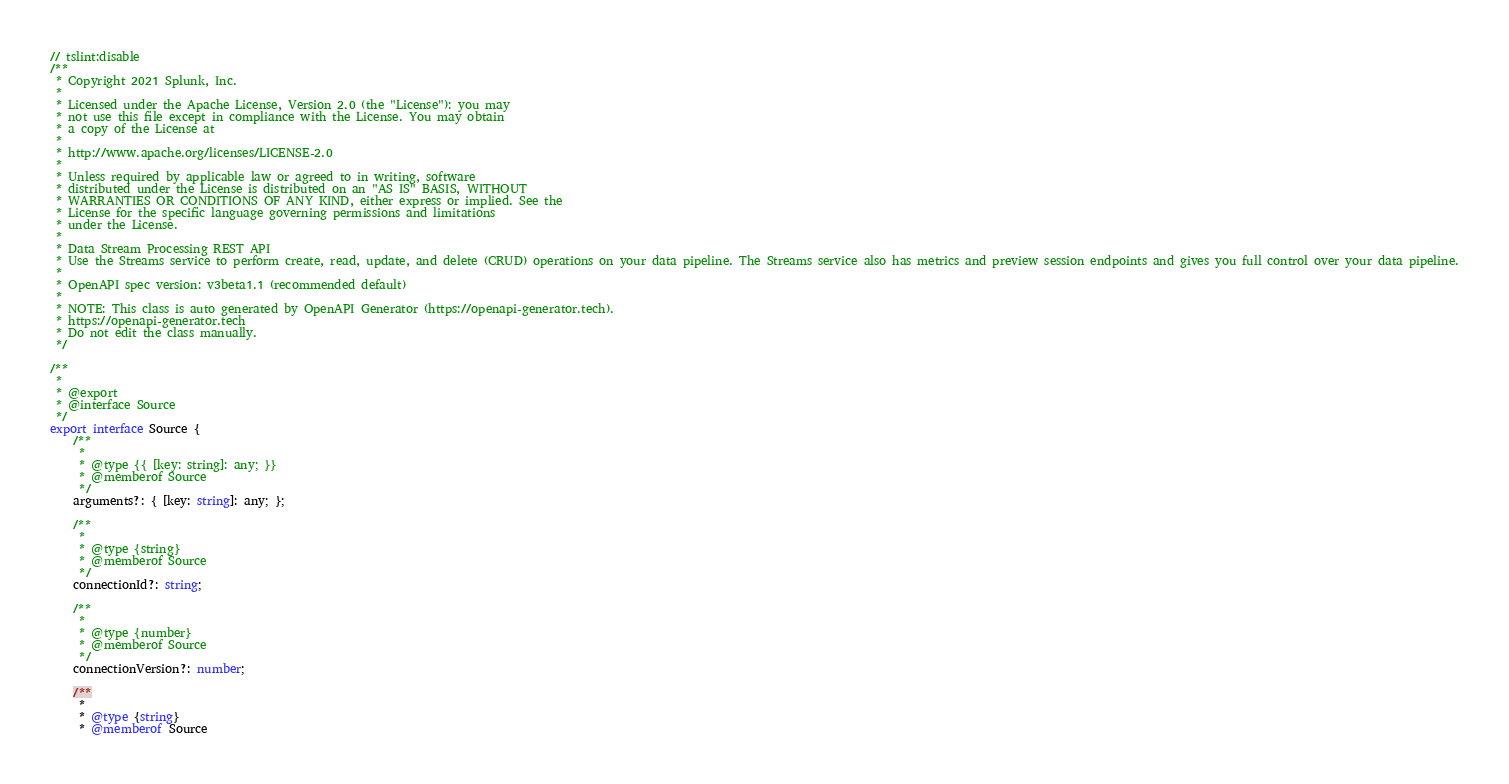Convert code to text. <code><loc_0><loc_0><loc_500><loc_500><_TypeScript_>// tslint:disable
/**
 * Copyright 2021 Splunk, Inc.
 *
 * Licensed under the Apache License, Version 2.0 (the "License"): you may
 * not use this file except in compliance with the License. You may obtain
 * a copy of the License at
 *
 * http://www.apache.org/licenses/LICENSE-2.0
 *
 * Unless required by applicable law or agreed to in writing, software
 * distributed under the License is distributed on an "AS IS" BASIS, WITHOUT
 * WARRANTIES OR CONDITIONS OF ANY KIND, either express or implied. See the
 * License for the specific language governing permissions and limitations
 * under the License.
 *
 * Data Stream Processing REST API
 * Use the Streams service to perform create, read, update, and delete (CRUD) operations on your data pipeline. The Streams service also has metrics and preview session endpoints and gives you full control over your data pipeline.
 *
 * OpenAPI spec version: v3beta1.1 (recommended default)
 *
 * NOTE: This class is auto generated by OpenAPI Generator (https://openapi-generator.tech).
 * https://openapi-generator.tech
 * Do not edit the class manually.
 */

/**
 *
 * @export
 * @interface Source
 */
export interface Source {
    /**
     * 
     * @type {{ [key: string]: any; }}
     * @memberof Source
     */
    arguments?: { [key: string]: any; };

    /**
     * 
     * @type {string}
     * @memberof Source
     */
    connectionId?: string;

    /**
     * 
     * @type {number}
     * @memberof Source
     */
    connectionVersion?: number;

    /**
     * 
     * @type {string}
     * @memberof Source</code> 